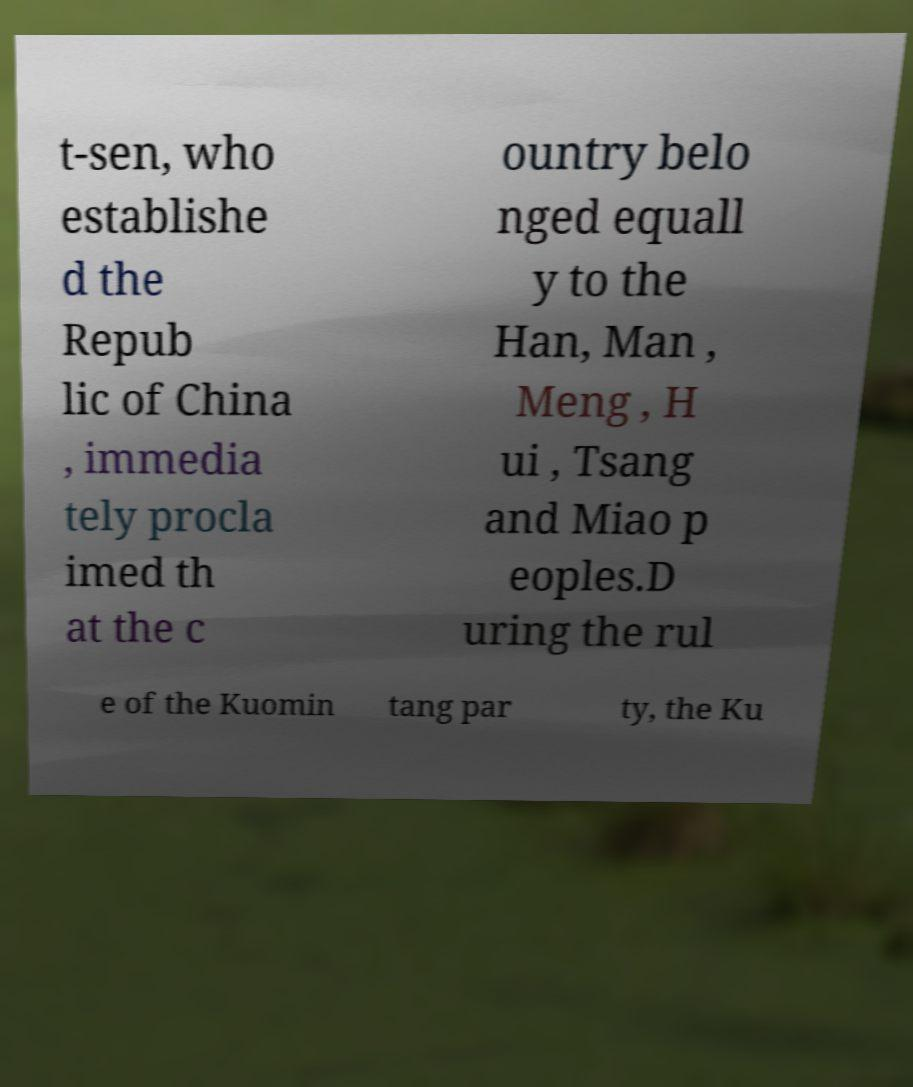There's text embedded in this image that I need extracted. Can you transcribe it verbatim? t-sen, who establishe d the Repub lic of China , immedia tely procla imed th at the c ountry belo nged equall y to the Han, Man , Meng , H ui , Tsang and Miao p eoples.D uring the rul e of the Kuomin tang par ty, the Ku 